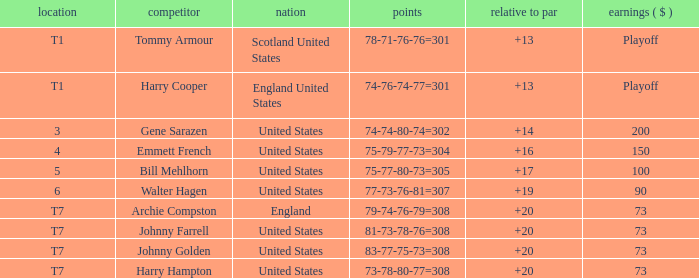What is the ranking for the United States when the money is $200? 3.0. Write the full table. {'header': ['location', 'competitor', 'nation', 'points', 'relative to par', 'earnings ( $ )'], 'rows': [['T1', 'Tommy Armour', 'Scotland United States', '78-71-76-76=301', '+13', 'Playoff'], ['T1', 'Harry Cooper', 'England United States', '74-76-74-77=301', '+13', 'Playoff'], ['3', 'Gene Sarazen', 'United States', '74-74-80-74=302', '+14', '200'], ['4', 'Emmett French', 'United States', '75-79-77-73=304', '+16', '150'], ['5', 'Bill Mehlhorn', 'United States', '75-77-80-73=305', '+17', '100'], ['6', 'Walter Hagen', 'United States', '77-73-76-81=307', '+19', '90'], ['T7', 'Archie Compston', 'England', '79-74-76-79=308', '+20', '73'], ['T7', 'Johnny Farrell', 'United States', '81-73-78-76=308', '+20', '73'], ['T7', 'Johnny Golden', 'United States', '83-77-75-73=308', '+20', '73'], ['T7', 'Harry Hampton', 'United States', '73-78-80-77=308', '+20', '73']]} 